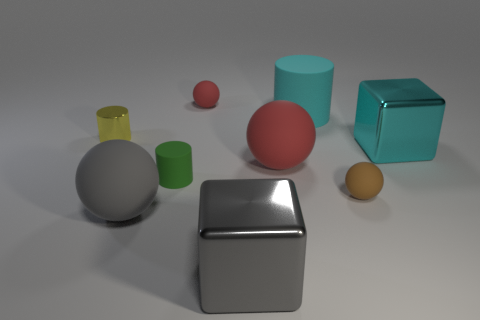Subtract all cylinders. How many objects are left? 6 Add 2 red matte objects. How many red matte objects exist? 4 Subtract 1 gray balls. How many objects are left? 8 Subtract all big purple rubber spheres. Subtract all big metallic objects. How many objects are left? 7 Add 2 red matte spheres. How many red matte spheres are left? 4 